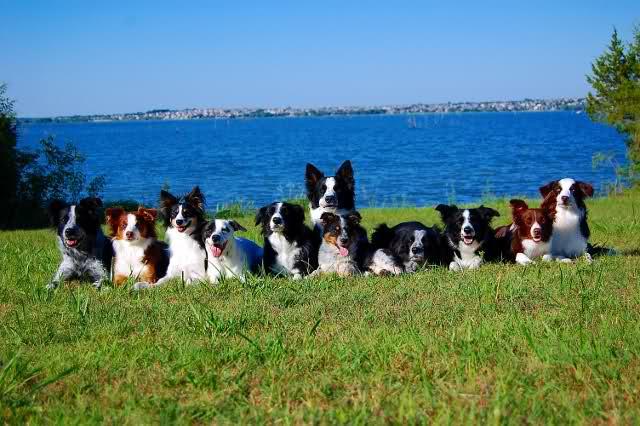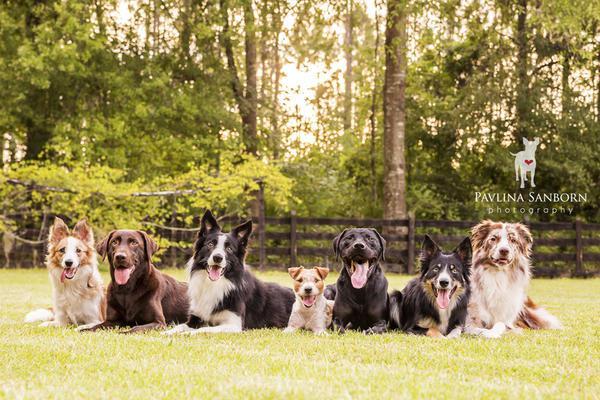The first image is the image on the left, the second image is the image on the right. Examine the images to the left and right. Is the description "There are exactly seven dogs in the image on the right." accurate? Answer yes or no. Yes. 